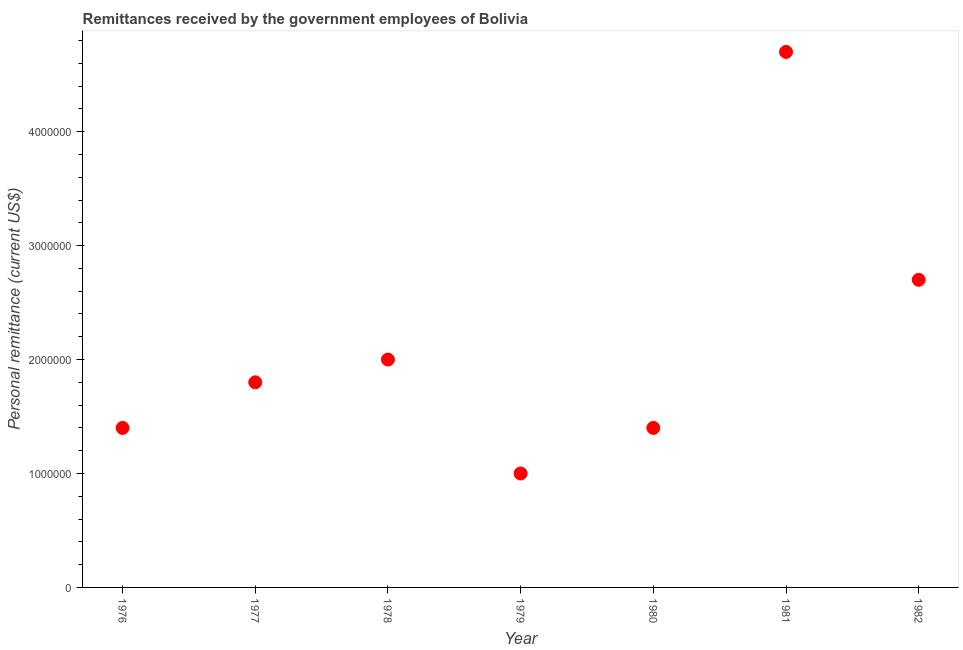What is the personal remittances in 1977?
Offer a very short reply. 1.80e+06. Across all years, what is the maximum personal remittances?
Provide a short and direct response. 4.70e+06. In which year was the personal remittances maximum?
Offer a very short reply. 1981. In which year was the personal remittances minimum?
Make the answer very short. 1979. What is the sum of the personal remittances?
Make the answer very short. 1.50e+07. What is the difference between the personal remittances in 1980 and 1982?
Your answer should be very brief. -1.30e+06. What is the average personal remittances per year?
Provide a short and direct response. 2.14e+06. What is the median personal remittances?
Make the answer very short. 1.80e+06. Do a majority of the years between 1976 and 1980 (inclusive) have personal remittances greater than 2400000 US$?
Offer a very short reply. No. Is the personal remittances in 1977 less than that in 1982?
Offer a very short reply. Yes. Is the difference between the personal remittances in 1977 and 1982 greater than the difference between any two years?
Provide a short and direct response. No. What is the difference between the highest and the second highest personal remittances?
Offer a terse response. 2.00e+06. Is the sum of the personal remittances in 1978 and 1982 greater than the maximum personal remittances across all years?
Provide a succinct answer. Yes. What is the difference between the highest and the lowest personal remittances?
Your answer should be compact. 3.70e+06. In how many years, is the personal remittances greater than the average personal remittances taken over all years?
Your answer should be very brief. 2. Does the personal remittances monotonically increase over the years?
Give a very brief answer. No. How many dotlines are there?
Your answer should be very brief. 1. How many years are there in the graph?
Your answer should be compact. 7. Are the values on the major ticks of Y-axis written in scientific E-notation?
Your answer should be very brief. No. Does the graph contain any zero values?
Make the answer very short. No. What is the title of the graph?
Your response must be concise. Remittances received by the government employees of Bolivia. What is the label or title of the X-axis?
Your answer should be compact. Year. What is the label or title of the Y-axis?
Offer a very short reply. Personal remittance (current US$). What is the Personal remittance (current US$) in 1976?
Provide a short and direct response. 1.40e+06. What is the Personal remittance (current US$) in 1977?
Offer a terse response. 1.80e+06. What is the Personal remittance (current US$) in 1978?
Keep it short and to the point. 2.00e+06. What is the Personal remittance (current US$) in 1980?
Ensure brevity in your answer.  1.40e+06. What is the Personal remittance (current US$) in 1981?
Give a very brief answer. 4.70e+06. What is the Personal remittance (current US$) in 1982?
Your answer should be very brief. 2.70e+06. What is the difference between the Personal remittance (current US$) in 1976 and 1977?
Keep it short and to the point. -4.00e+05. What is the difference between the Personal remittance (current US$) in 1976 and 1978?
Your response must be concise. -6.00e+05. What is the difference between the Personal remittance (current US$) in 1976 and 1979?
Ensure brevity in your answer.  4.00e+05. What is the difference between the Personal remittance (current US$) in 1976 and 1981?
Your response must be concise. -3.30e+06. What is the difference between the Personal remittance (current US$) in 1976 and 1982?
Your answer should be very brief. -1.30e+06. What is the difference between the Personal remittance (current US$) in 1977 and 1978?
Offer a very short reply. -2.00e+05. What is the difference between the Personal remittance (current US$) in 1977 and 1979?
Offer a terse response. 8.00e+05. What is the difference between the Personal remittance (current US$) in 1977 and 1980?
Keep it short and to the point. 4.00e+05. What is the difference between the Personal remittance (current US$) in 1977 and 1981?
Offer a terse response. -2.90e+06. What is the difference between the Personal remittance (current US$) in 1977 and 1982?
Offer a very short reply. -9.00e+05. What is the difference between the Personal remittance (current US$) in 1978 and 1979?
Provide a succinct answer. 1.00e+06. What is the difference between the Personal remittance (current US$) in 1978 and 1980?
Offer a very short reply. 6.00e+05. What is the difference between the Personal remittance (current US$) in 1978 and 1981?
Provide a succinct answer. -2.70e+06. What is the difference between the Personal remittance (current US$) in 1978 and 1982?
Provide a short and direct response. -7.00e+05. What is the difference between the Personal remittance (current US$) in 1979 and 1980?
Make the answer very short. -4.00e+05. What is the difference between the Personal remittance (current US$) in 1979 and 1981?
Give a very brief answer. -3.70e+06. What is the difference between the Personal remittance (current US$) in 1979 and 1982?
Offer a very short reply. -1.70e+06. What is the difference between the Personal remittance (current US$) in 1980 and 1981?
Offer a very short reply. -3.30e+06. What is the difference between the Personal remittance (current US$) in 1980 and 1982?
Provide a short and direct response. -1.30e+06. What is the difference between the Personal remittance (current US$) in 1981 and 1982?
Your answer should be compact. 2.00e+06. What is the ratio of the Personal remittance (current US$) in 1976 to that in 1977?
Your response must be concise. 0.78. What is the ratio of the Personal remittance (current US$) in 1976 to that in 1981?
Keep it short and to the point. 0.3. What is the ratio of the Personal remittance (current US$) in 1976 to that in 1982?
Your response must be concise. 0.52. What is the ratio of the Personal remittance (current US$) in 1977 to that in 1978?
Give a very brief answer. 0.9. What is the ratio of the Personal remittance (current US$) in 1977 to that in 1979?
Your answer should be compact. 1.8. What is the ratio of the Personal remittance (current US$) in 1977 to that in 1980?
Make the answer very short. 1.29. What is the ratio of the Personal remittance (current US$) in 1977 to that in 1981?
Provide a succinct answer. 0.38. What is the ratio of the Personal remittance (current US$) in 1977 to that in 1982?
Give a very brief answer. 0.67. What is the ratio of the Personal remittance (current US$) in 1978 to that in 1979?
Your answer should be very brief. 2. What is the ratio of the Personal remittance (current US$) in 1978 to that in 1980?
Make the answer very short. 1.43. What is the ratio of the Personal remittance (current US$) in 1978 to that in 1981?
Make the answer very short. 0.43. What is the ratio of the Personal remittance (current US$) in 1978 to that in 1982?
Keep it short and to the point. 0.74. What is the ratio of the Personal remittance (current US$) in 1979 to that in 1980?
Your answer should be compact. 0.71. What is the ratio of the Personal remittance (current US$) in 1979 to that in 1981?
Offer a very short reply. 0.21. What is the ratio of the Personal remittance (current US$) in 1979 to that in 1982?
Your response must be concise. 0.37. What is the ratio of the Personal remittance (current US$) in 1980 to that in 1981?
Make the answer very short. 0.3. What is the ratio of the Personal remittance (current US$) in 1980 to that in 1982?
Give a very brief answer. 0.52. What is the ratio of the Personal remittance (current US$) in 1981 to that in 1982?
Your answer should be compact. 1.74. 